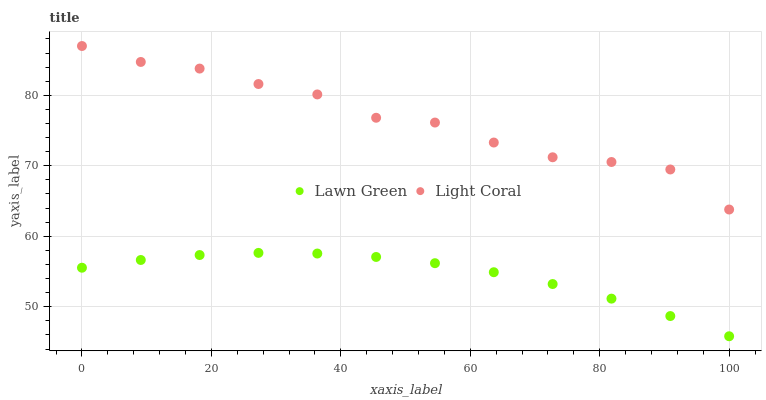Does Lawn Green have the minimum area under the curve?
Answer yes or no. Yes. Does Light Coral have the maximum area under the curve?
Answer yes or no. Yes. Does Lawn Green have the maximum area under the curve?
Answer yes or no. No. Is Lawn Green the smoothest?
Answer yes or no. Yes. Is Light Coral the roughest?
Answer yes or no. Yes. Is Lawn Green the roughest?
Answer yes or no. No. Does Lawn Green have the lowest value?
Answer yes or no. Yes. Does Light Coral have the highest value?
Answer yes or no. Yes. Does Lawn Green have the highest value?
Answer yes or no. No. Is Lawn Green less than Light Coral?
Answer yes or no. Yes. Is Light Coral greater than Lawn Green?
Answer yes or no. Yes. Does Lawn Green intersect Light Coral?
Answer yes or no. No. 